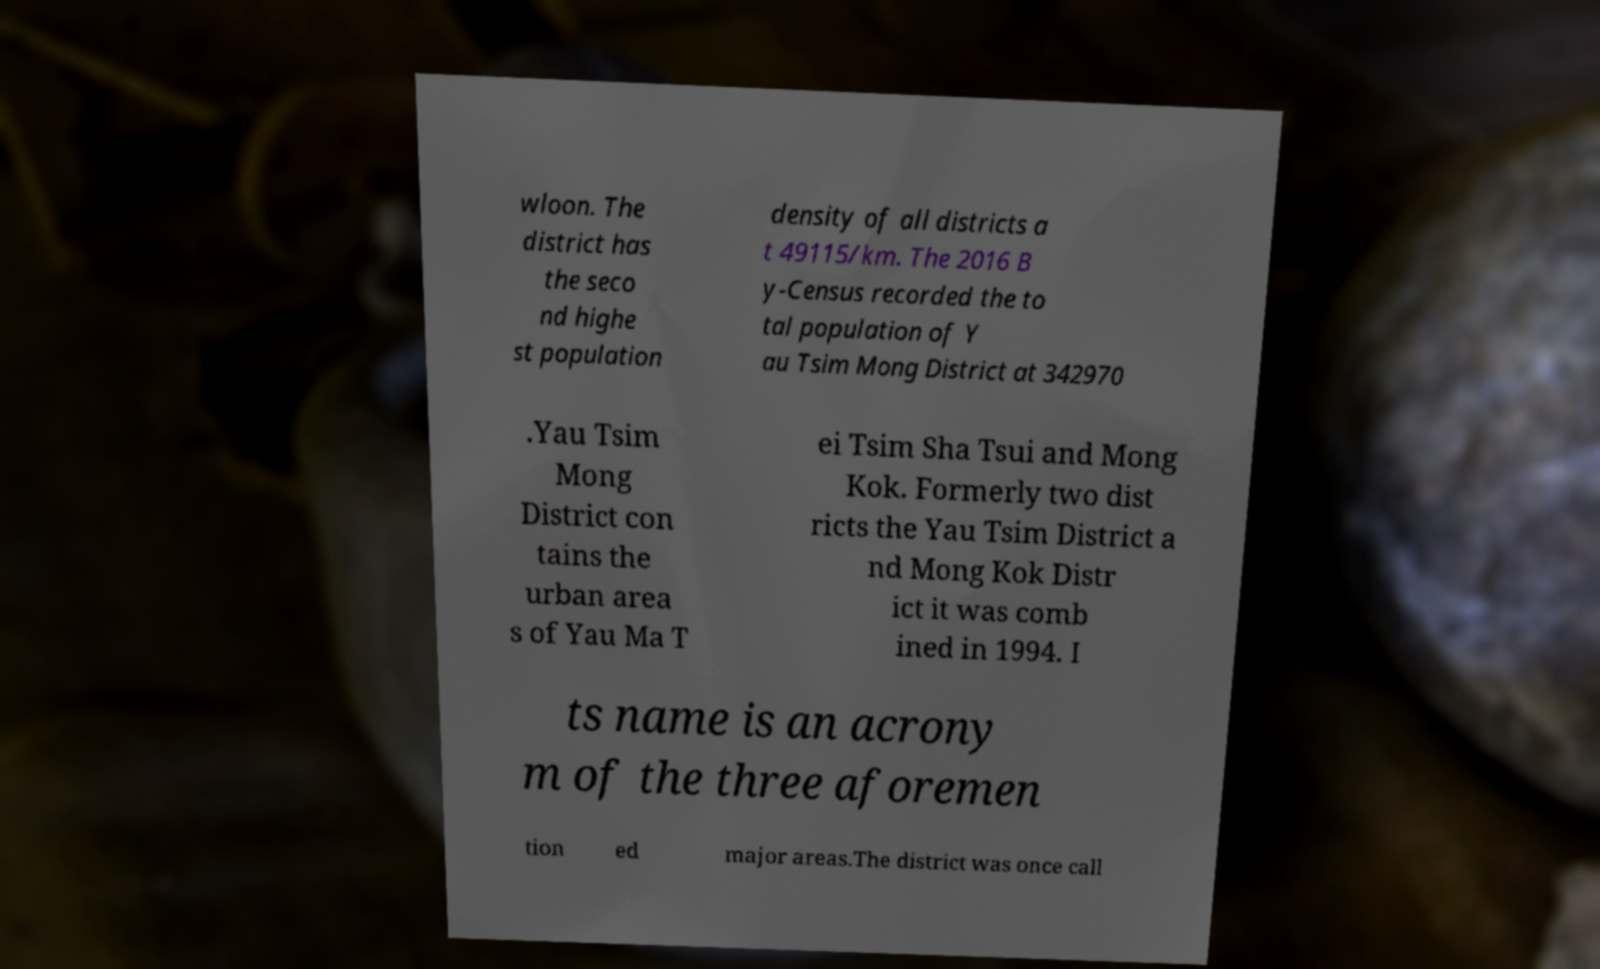There's text embedded in this image that I need extracted. Can you transcribe it verbatim? wloon. The district has the seco nd highe st population density of all districts a t 49115/km. The 2016 B y-Census recorded the to tal population of Y au Tsim Mong District at 342970 .Yau Tsim Mong District con tains the urban area s of Yau Ma T ei Tsim Sha Tsui and Mong Kok. Formerly two dist ricts the Yau Tsim District a nd Mong Kok Distr ict it was comb ined in 1994. I ts name is an acrony m of the three aforemen tion ed major areas.The district was once call 